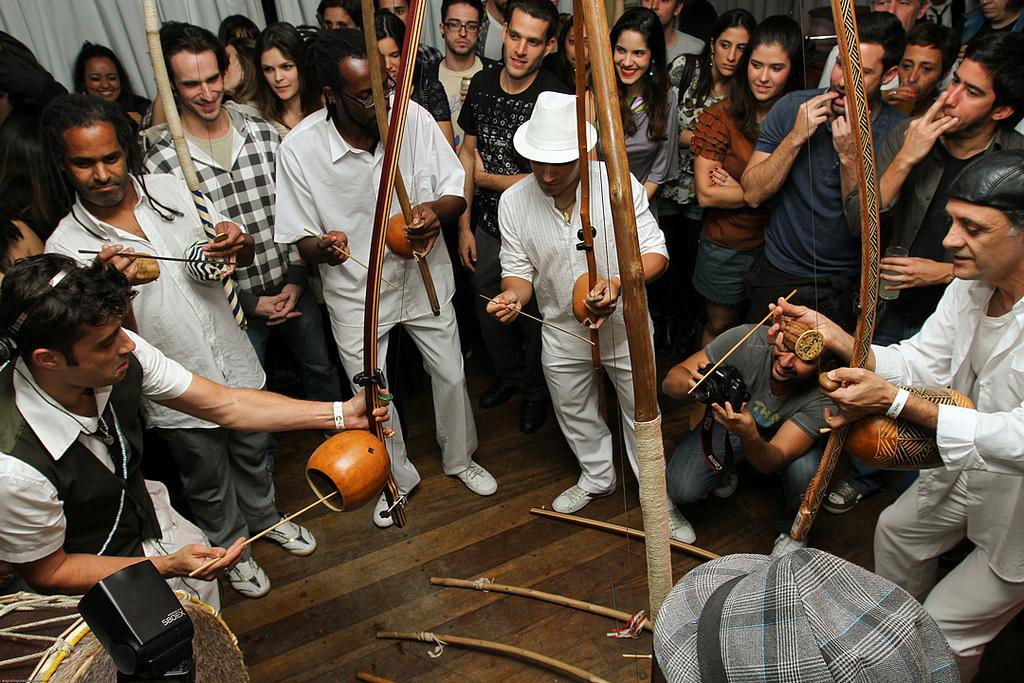How many people are present in the image? There are many people in the image. What are some of the people doing in the image? Some people are playing musical instruments. Can you describe the appearance of one person in the image? There is a person wearing a hat. What is visible at the top of the image? There is a curtain visible at the top of the image. Who might be responsible for capturing the image? There is a person holding a camera in the image. What type of birds can be seen flying in the image? There are no birds visible in the image. Can you describe the smile of the person holding the camera? There is no mention of a smile in the image, as it does not describe the facial expressions of the people present. 